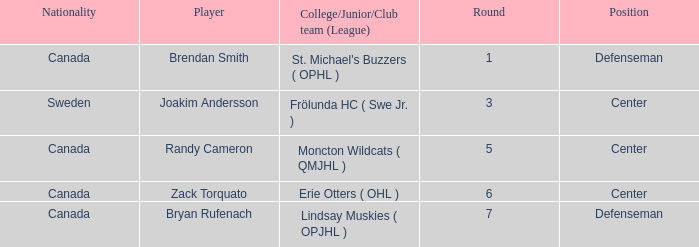Where does center Joakim Andersson come from? Sweden. 